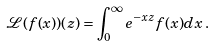<formula> <loc_0><loc_0><loc_500><loc_500>\mathcal { L ( } f ( x ) ) ( z ) = \int _ { 0 } ^ { \infty } e ^ { - x z } f ( x ) d x \, .</formula> 